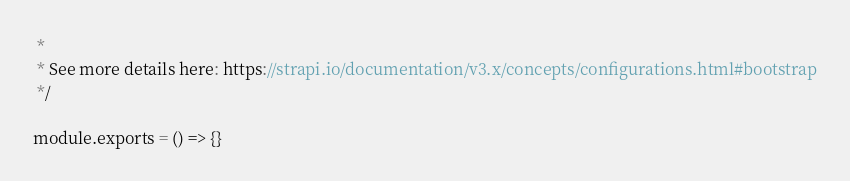Convert code to text. <code><loc_0><loc_0><loc_500><loc_500><_JavaScript_> *
 * See more details here: https://strapi.io/documentation/v3.x/concepts/configurations.html#bootstrap
 */

module.exports = () => {}
</code> 